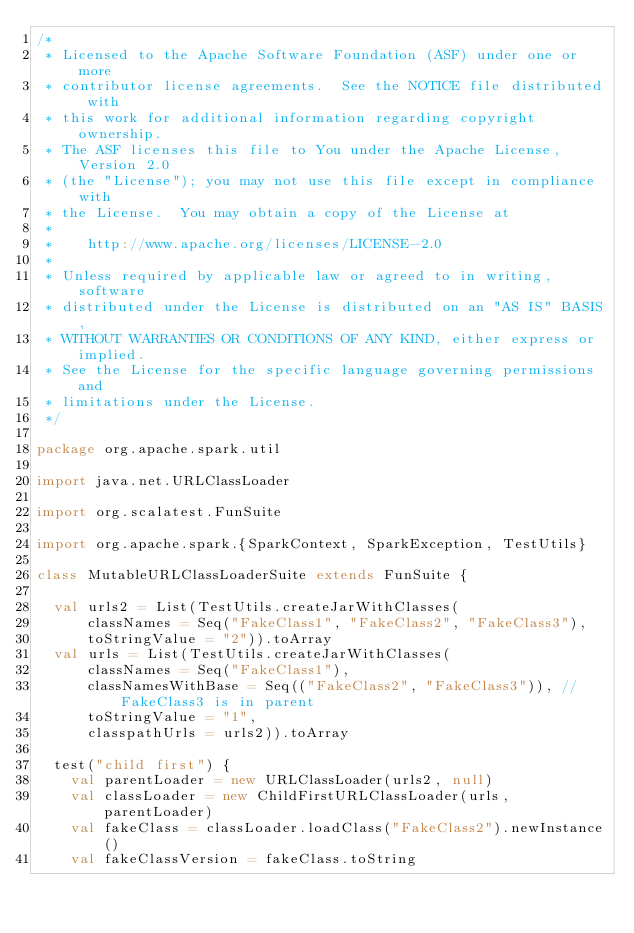<code> <loc_0><loc_0><loc_500><loc_500><_Scala_>/*
 * Licensed to the Apache Software Foundation (ASF) under one or more
 * contributor license agreements.  See the NOTICE file distributed with
 * this work for additional information regarding copyright ownership.
 * The ASF licenses this file to You under the Apache License, Version 2.0
 * (the "License"); you may not use this file except in compliance with
 * the License.  You may obtain a copy of the License at
 *
 *    http://www.apache.org/licenses/LICENSE-2.0
 *
 * Unless required by applicable law or agreed to in writing, software
 * distributed under the License is distributed on an "AS IS" BASIS,
 * WITHOUT WARRANTIES OR CONDITIONS OF ANY KIND, either express or implied.
 * See the License for the specific language governing permissions and
 * limitations under the License.
 */

package org.apache.spark.util

import java.net.URLClassLoader

import org.scalatest.FunSuite

import org.apache.spark.{SparkContext, SparkException, TestUtils}

class MutableURLClassLoaderSuite extends FunSuite {

  val urls2 = List(TestUtils.createJarWithClasses(
      classNames = Seq("FakeClass1", "FakeClass2", "FakeClass3"),
      toStringValue = "2")).toArray
  val urls = List(TestUtils.createJarWithClasses(
      classNames = Seq("FakeClass1"),
      classNamesWithBase = Seq(("FakeClass2", "FakeClass3")), // FakeClass3 is in parent
      toStringValue = "1",
      classpathUrls = urls2)).toArray

  test("child first") {
    val parentLoader = new URLClassLoader(urls2, null)
    val classLoader = new ChildFirstURLClassLoader(urls, parentLoader)
    val fakeClass = classLoader.loadClass("FakeClass2").newInstance()
    val fakeClassVersion = fakeClass.toString</code> 